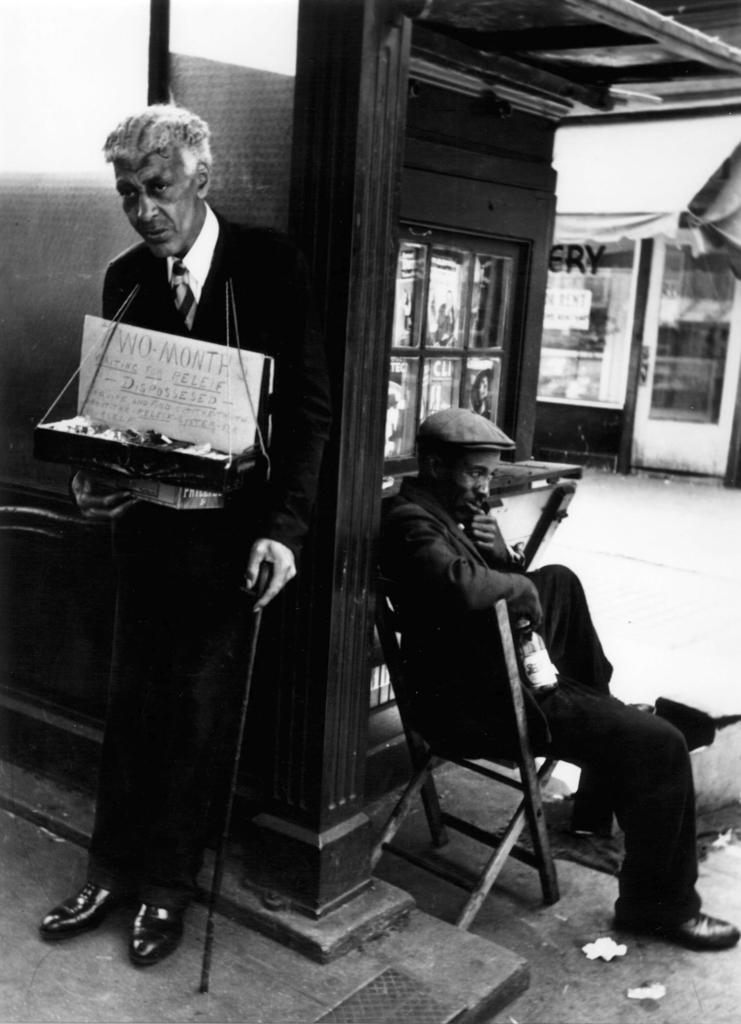Please provide a concise description of this image. In this image we can see two persons wearing black color suit and one of the person carrying some food tray standing and leaning to the wall, holding a stick and a person sitting on a chair and in the background of the image there is some store. 